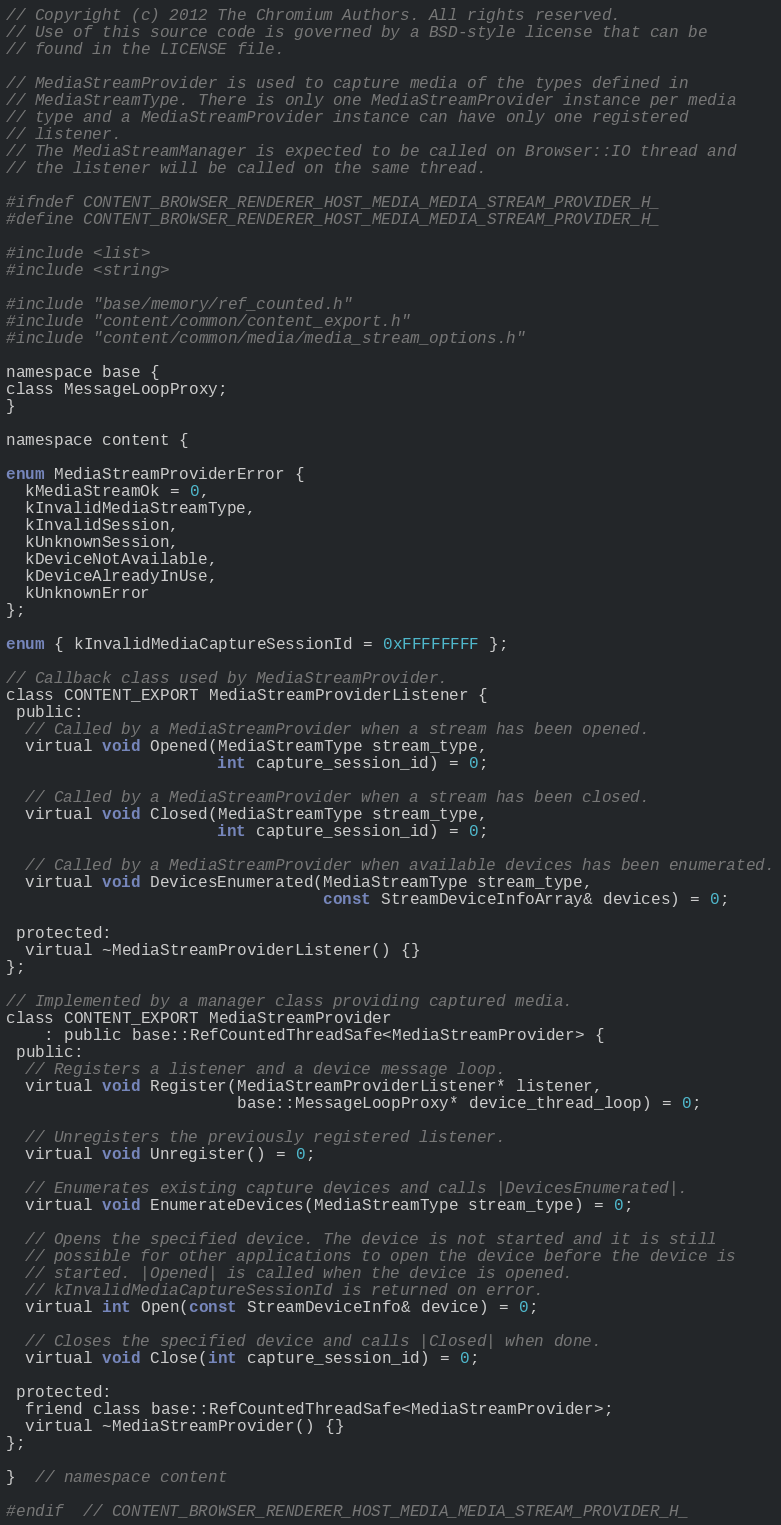Convert code to text. <code><loc_0><loc_0><loc_500><loc_500><_C_>// Copyright (c) 2012 The Chromium Authors. All rights reserved.
// Use of this source code is governed by a BSD-style license that can be
// found in the LICENSE file.

// MediaStreamProvider is used to capture media of the types defined in
// MediaStreamType. There is only one MediaStreamProvider instance per media
// type and a MediaStreamProvider instance can have only one registered
// listener.
// The MediaStreamManager is expected to be called on Browser::IO thread and
// the listener will be called on the same thread.

#ifndef CONTENT_BROWSER_RENDERER_HOST_MEDIA_MEDIA_STREAM_PROVIDER_H_
#define CONTENT_BROWSER_RENDERER_HOST_MEDIA_MEDIA_STREAM_PROVIDER_H_

#include <list>
#include <string>

#include "base/memory/ref_counted.h"
#include "content/common/content_export.h"
#include "content/common/media/media_stream_options.h"

namespace base {
class MessageLoopProxy;
}

namespace content {

enum MediaStreamProviderError {
  kMediaStreamOk = 0,
  kInvalidMediaStreamType,
  kInvalidSession,
  kUnknownSession,
  kDeviceNotAvailable,
  kDeviceAlreadyInUse,
  kUnknownError
};

enum { kInvalidMediaCaptureSessionId = 0xFFFFFFFF };

// Callback class used by MediaStreamProvider.
class CONTENT_EXPORT MediaStreamProviderListener {
 public:
  // Called by a MediaStreamProvider when a stream has been opened.
  virtual void Opened(MediaStreamType stream_type,
                      int capture_session_id) = 0;

  // Called by a MediaStreamProvider when a stream has been closed.
  virtual void Closed(MediaStreamType stream_type,
                      int capture_session_id) = 0;

  // Called by a MediaStreamProvider when available devices has been enumerated.
  virtual void DevicesEnumerated(MediaStreamType stream_type,
                                 const StreamDeviceInfoArray& devices) = 0;

 protected:
  virtual ~MediaStreamProviderListener() {}
};

// Implemented by a manager class providing captured media.
class CONTENT_EXPORT MediaStreamProvider
    : public base::RefCountedThreadSafe<MediaStreamProvider> {
 public:
  // Registers a listener and a device message loop.
  virtual void Register(MediaStreamProviderListener* listener,
                        base::MessageLoopProxy* device_thread_loop) = 0;

  // Unregisters the previously registered listener.
  virtual void Unregister() = 0;

  // Enumerates existing capture devices and calls |DevicesEnumerated|.
  virtual void EnumerateDevices(MediaStreamType stream_type) = 0;

  // Opens the specified device. The device is not started and it is still
  // possible for other applications to open the device before the device is
  // started. |Opened| is called when the device is opened.
  // kInvalidMediaCaptureSessionId is returned on error.
  virtual int Open(const StreamDeviceInfo& device) = 0;

  // Closes the specified device and calls |Closed| when done.
  virtual void Close(int capture_session_id) = 0;

 protected:
  friend class base::RefCountedThreadSafe<MediaStreamProvider>;
  virtual ~MediaStreamProvider() {}
};

}  // namespace content

#endif  // CONTENT_BROWSER_RENDERER_HOST_MEDIA_MEDIA_STREAM_PROVIDER_H_
</code> 